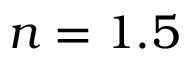Convert formula to latex. <formula><loc_0><loc_0><loc_500><loc_500>n = 1 . 5</formula> 